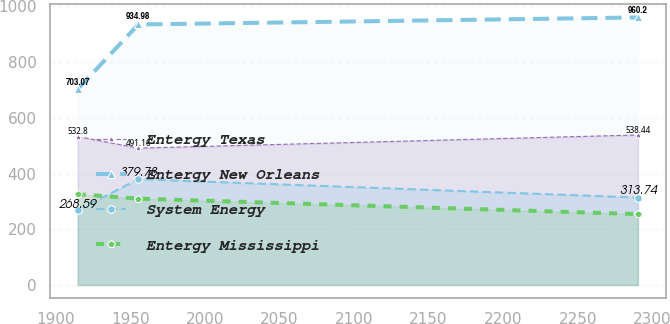Convert chart to OTSL. <chart><loc_0><loc_0><loc_500><loc_500><line_chart><ecel><fcel>Entergy Texas<fcel>Entergy New Orleans<fcel>System Energy<fcel>Entergy Mississippi<nl><fcel>1914.74<fcel>532.8<fcel>703.07<fcel>268.59<fcel>325.98<nl><fcel>1955.36<fcel>491.16<fcel>934.98<fcel>379.78<fcel>309.96<nl><fcel>2290.41<fcel>538.44<fcel>960.2<fcel>313.74<fcel>254.45<nl></chart> 